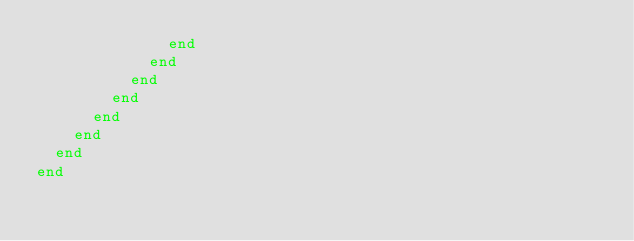Convert code to text. <code><loc_0><loc_0><loc_500><loc_500><_Ruby_>              end
            end
          end
        end
      end
    end
  end
end

</code> 